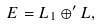Convert formula to latex. <formula><loc_0><loc_0><loc_500><loc_500>E = L _ { 1 } \oplus ^ { \prime } L ,</formula> 